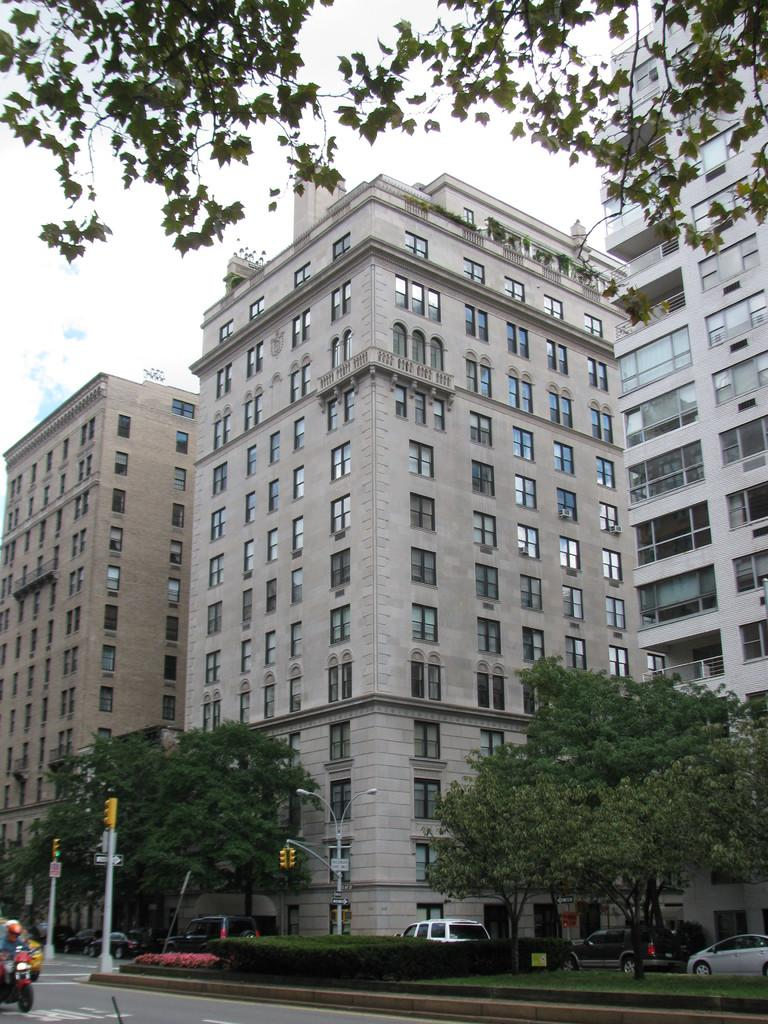What can be seen on the road in the image? There are vehicles on the road in the image. What helps regulate traffic in the image? There are signal lights in the image. What type of signage is present in the image? There are boards in the image. What type of lighting is present in the image? There are lights attached to poles in the image. What type of vegetation is present in the image? There are plants and trees in the image. What type of structures are present in the image? There are buildings in the image. What can be seen in the background of the image? The sky is visible in the background of the image. Can you tell me how many dogs are present in the image? There are no dogs present in the image. What type of pet is sitting on the judge's lap in the image? There is no judge or pet present in the image. 